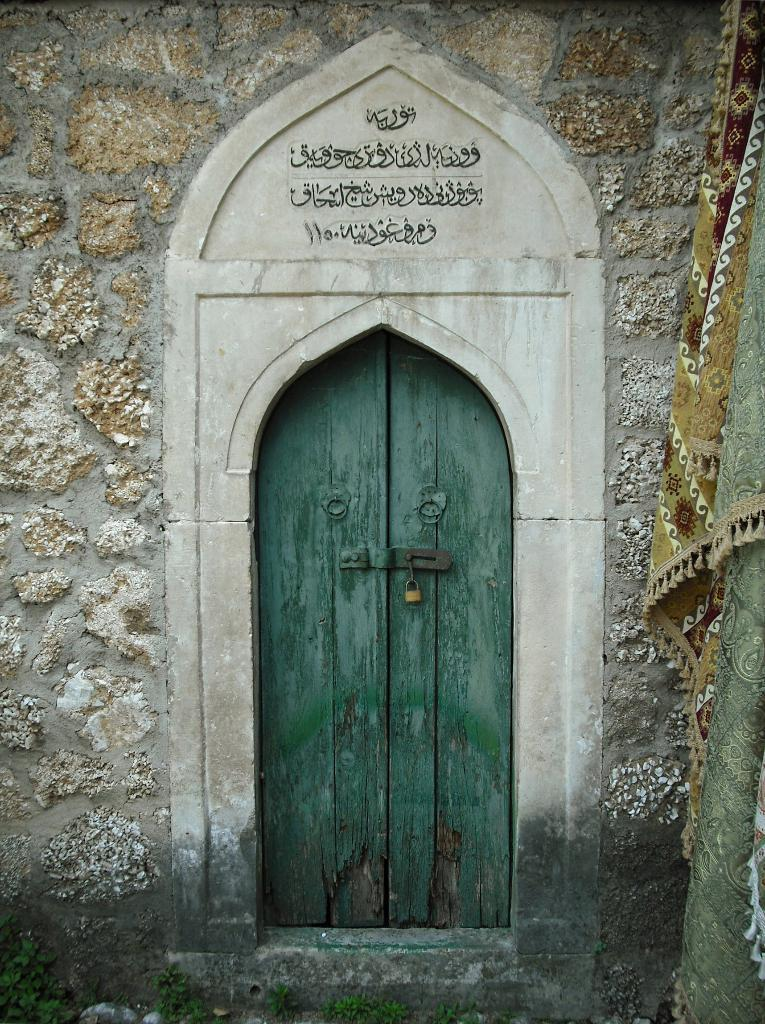What type of door is shown in the image? There is a wooden door in the image. Does the door have any security features? Yes, the door has a lock. What design element is present around the door? There is a marble design around the door. Is there any text associated with the door? Yes, there is some text on or near the door. What can be seen on the right-hand side of the image? Clothes are hanging on the right-hand side of the image. What is your opinion on the oven's performance in the image? There is no oven present in the image, so it is not possible to provide an opinion on its performance. 